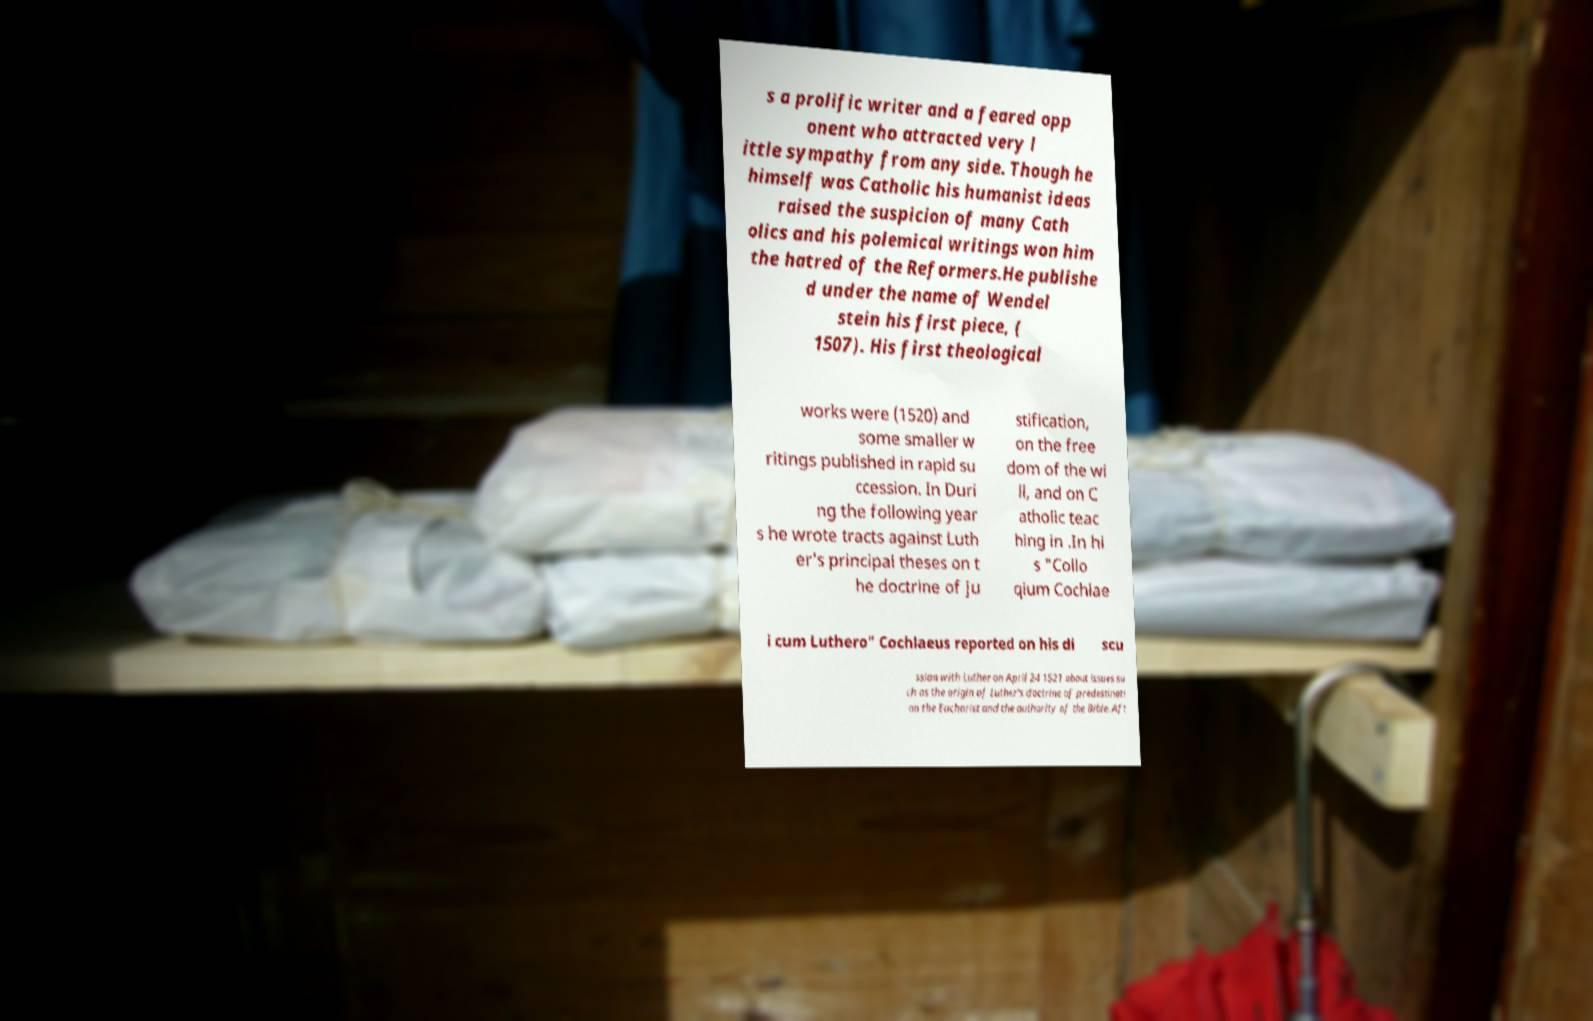Please read and relay the text visible in this image. What does it say? s a prolific writer and a feared opp onent who attracted very l ittle sympathy from any side. Though he himself was Catholic his humanist ideas raised the suspicion of many Cath olics and his polemical writings won him the hatred of the Reformers.He publishe d under the name of Wendel stein his first piece, ( 1507). His first theological works were (1520) and some smaller w ritings published in rapid su ccession. In Duri ng the following year s he wrote tracts against Luth er's principal theses on t he doctrine of ju stification, on the free dom of the wi ll, and on C atholic teac hing in .In hi s "Collo qium Cochlae i cum Luthero" Cochlaeus reported on his di scu ssion with Luther on April 24 1521 about issues su ch as the origin of Luther's doctrine of predestinati on the Eucharist and the authority of the Bible. Aft 